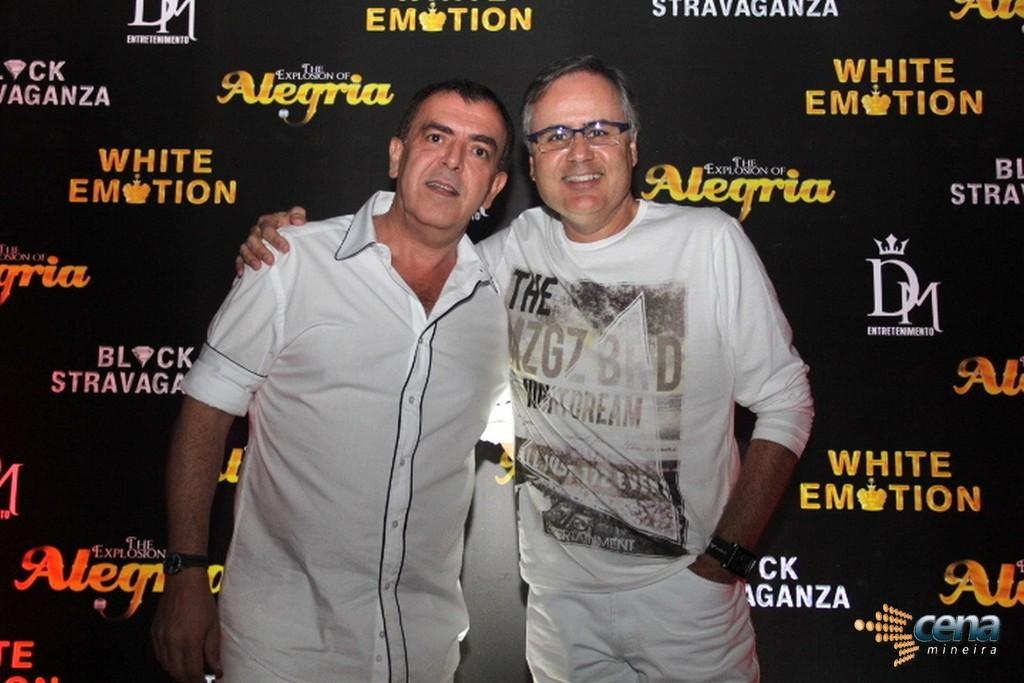<image>
Give a short and clear explanation of the subsequent image. Two men stand in front of a black background covered in words such as White Emotion. 